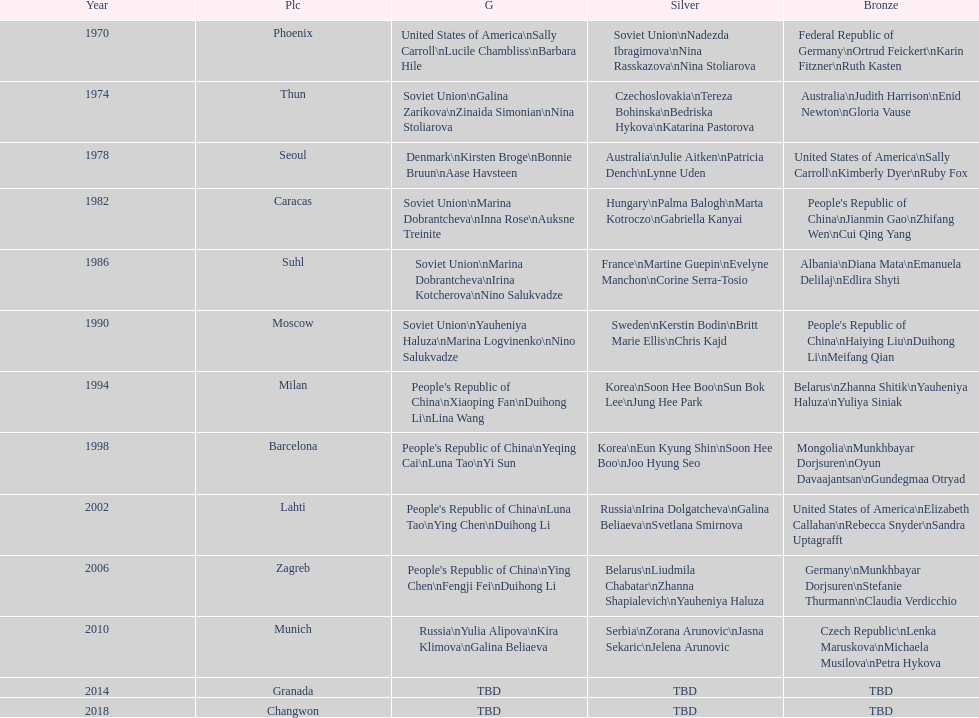Help me parse the entirety of this table. {'header': ['Year', 'Plc', 'G', 'Silver', 'Bronze'], 'rows': [['1970', 'Phoenix', 'United States of America\\nSally Carroll\\nLucile Chambliss\\nBarbara Hile', 'Soviet Union\\nNadezda Ibragimova\\nNina Rasskazova\\nNina Stoliarova', 'Federal Republic of Germany\\nOrtrud Feickert\\nKarin Fitzner\\nRuth Kasten'], ['1974', 'Thun', 'Soviet Union\\nGalina Zarikova\\nZinaida Simonian\\nNina Stoliarova', 'Czechoslovakia\\nTereza Bohinska\\nBedriska Hykova\\nKatarina Pastorova', 'Australia\\nJudith Harrison\\nEnid Newton\\nGloria Vause'], ['1978', 'Seoul', 'Denmark\\nKirsten Broge\\nBonnie Bruun\\nAase Havsteen', 'Australia\\nJulie Aitken\\nPatricia Dench\\nLynne Uden', 'United States of America\\nSally Carroll\\nKimberly Dyer\\nRuby Fox'], ['1982', 'Caracas', 'Soviet Union\\nMarina Dobrantcheva\\nInna Rose\\nAuksne Treinite', 'Hungary\\nPalma Balogh\\nMarta Kotroczo\\nGabriella Kanyai', "People's Republic of China\\nJianmin Gao\\nZhifang Wen\\nCui Qing Yang"], ['1986', 'Suhl', 'Soviet Union\\nMarina Dobrantcheva\\nIrina Kotcherova\\nNino Salukvadze', 'France\\nMartine Guepin\\nEvelyne Manchon\\nCorine Serra-Tosio', 'Albania\\nDiana Mata\\nEmanuela Delilaj\\nEdlira Shyti'], ['1990', 'Moscow', 'Soviet Union\\nYauheniya Haluza\\nMarina Logvinenko\\nNino Salukvadze', 'Sweden\\nKerstin Bodin\\nBritt Marie Ellis\\nChris Kajd', "People's Republic of China\\nHaiying Liu\\nDuihong Li\\nMeifang Qian"], ['1994', 'Milan', "People's Republic of China\\nXiaoping Fan\\nDuihong Li\\nLina Wang", 'Korea\\nSoon Hee Boo\\nSun Bok Lee\\nJung Hee Park', 'Belarus\\nZhanna Shitik\\nYauheniya Haluza\\nYuliya Siniak'], ['1998', 'Barcelona', "People's Republic of China\\nYeqing Cai\\nLuna Tao\\nYi Sun", 'Korea\\nEun Kyung Shin\\nSoon Hee Boo\\nJoo Hyung Seo', 'Mongolia\\nMunkhbayar Dorjsuren\\nOyun Davaajantsan\\nGundegmaa Otryad'], ['2002', 'Lahti', "People's Republic of China\\nLuna Tao\\nYing Chen\\nDuihong Li", 'Russia\\nIrina Dolgatcheva\\nGalina Beliaeva\\nSvetlana Smirnova', 'United States of America\\nElizabeth Callahan\\nRebecca Snyder\\nSandra Uptagrafft'], ['2006', 'Zagreb', "People's Republic of China\\nYing Chen\\nFengji Fei\\nDuihong Li", 'Belarus\\nLiudmila Chabatar\\nZhanna Shapialevich\\nYauheniya Haluza', 'Germany\\nMunkhbayar Dorjsuren\\nStefanie Thurmann\\nClaudia Verdicchio'], ['2010', 'Munich', 'Russia\\nYulia Alipova\\nKira Klimova\\nGalina Beliaeva', 'Serbia\\nZorana Arunovic\\nJasna Sekaric\\nJelena Arunovic', 'Czech Republic\\nLenka Maruskova\\nMichaela Musilova\\nPetra Hykova'], ['2014', 'Granada', 'TBD', 'TBD', 'TBD'], ['2018', 'Changwon', 'TBD', 'TBD', 'TBD']]} How many world championships had the soviet union won first place in in the 25 metre pistol women's world championship? 4. 